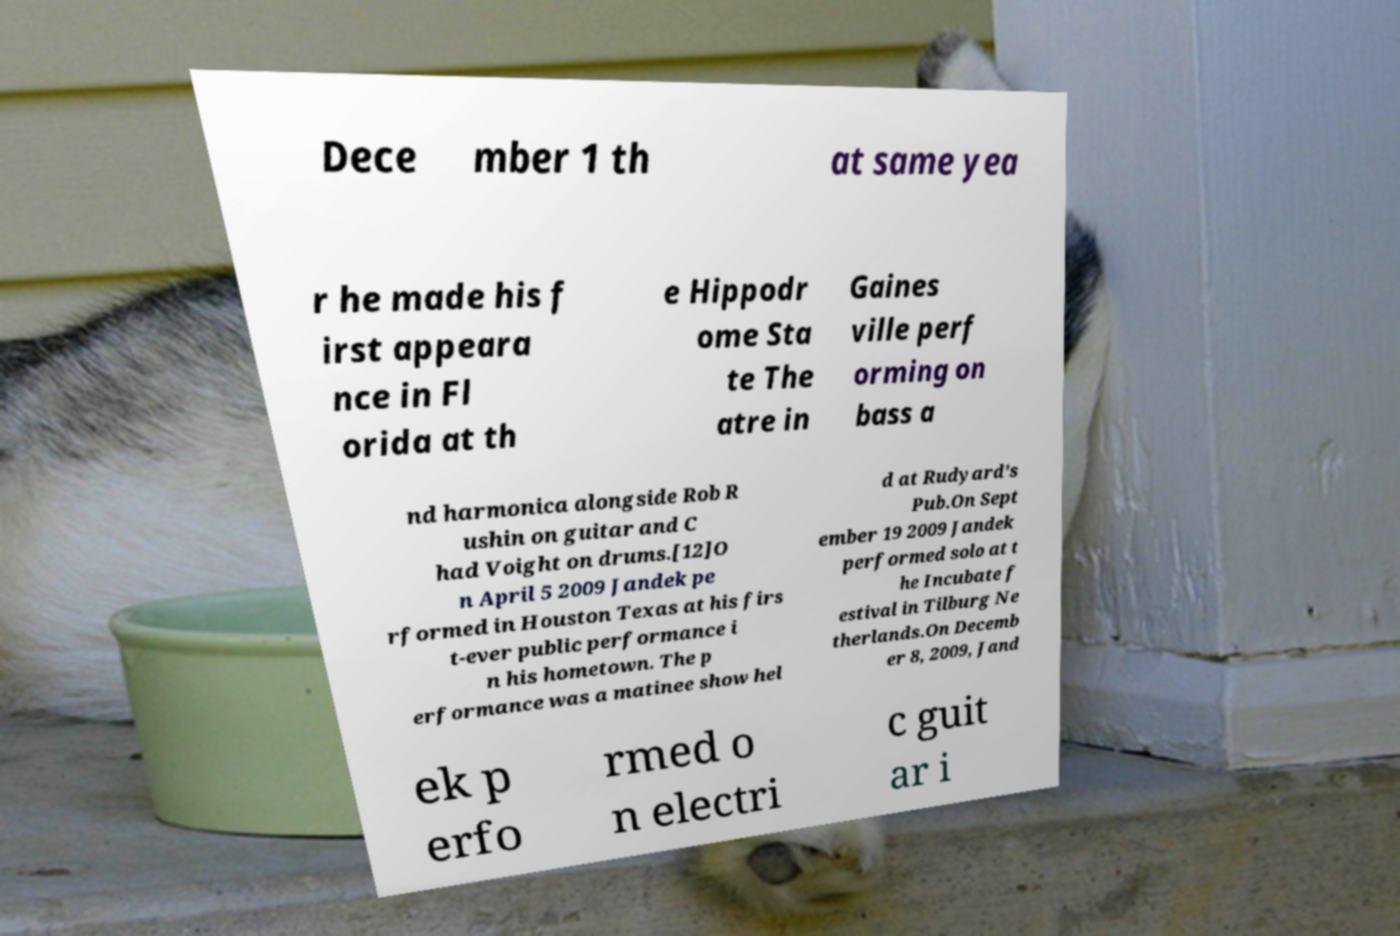Can you read and provide the text displayed in the image?This photo seems to have some interesting text. Can you extract and type it out for me? Dece mber 1 th at same yea r he made his f irst appeara nce in Fl orida at th e Hippodr ome Sta te The atre in Gaines ville perf orming on bass a nd harmonica alongside Rob R ushin on guitar and C had Voight on drums.[12]O n April 5 2009 Jandek pe rformed in Houston Texas at his firs t-ever public performance i n his hometown. The p erformance was a matinee show hel d at Rudyard's Pub.On Sept ember 19 2009 Jandek performed solo at t he Incubate f estival in Tilburg Ne therlands.On Decemb er 8, 2009, Jand ek p erfo rmed o n electri c guit ar i 